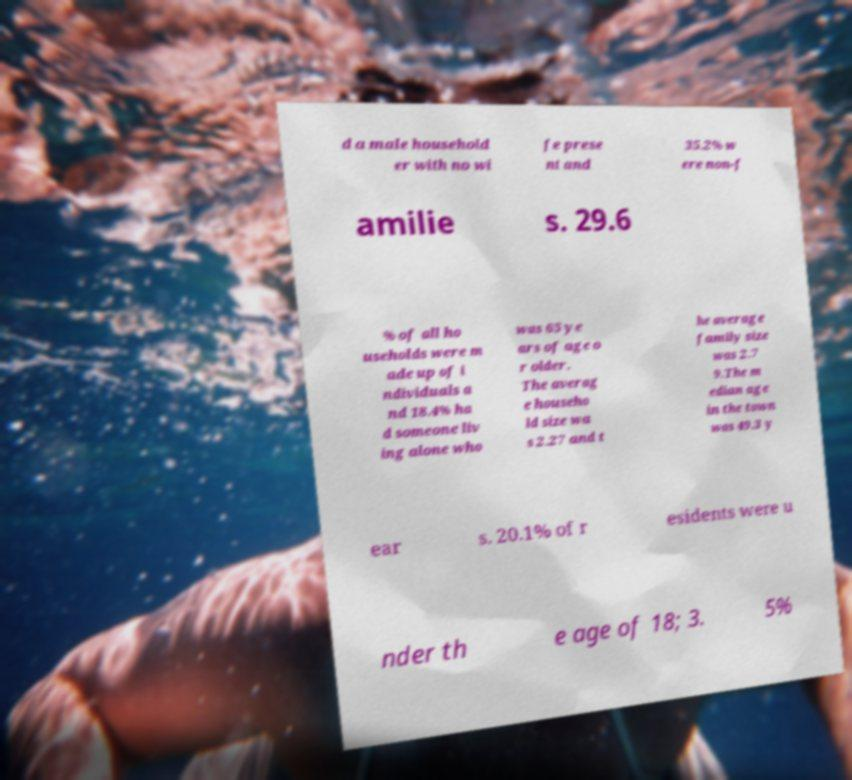I need the written content from this picture converted into text. Can you do that? d a male household er with no wi fe prese nt and 35.2% w ere non-f amilie s. 29.6 % of all ho useholds were m ade up of i ndividuals a nd 18.4% ha d someone liv ing alone who was 65 ye ars of age o r older. The averag e househo ld size wa s 2.27 and t he average family size was 2.7 9.The m edian age in the town was 49.3 y ear s. 20.1% of r esidents were u nder th e age of 18; 3. 5% 